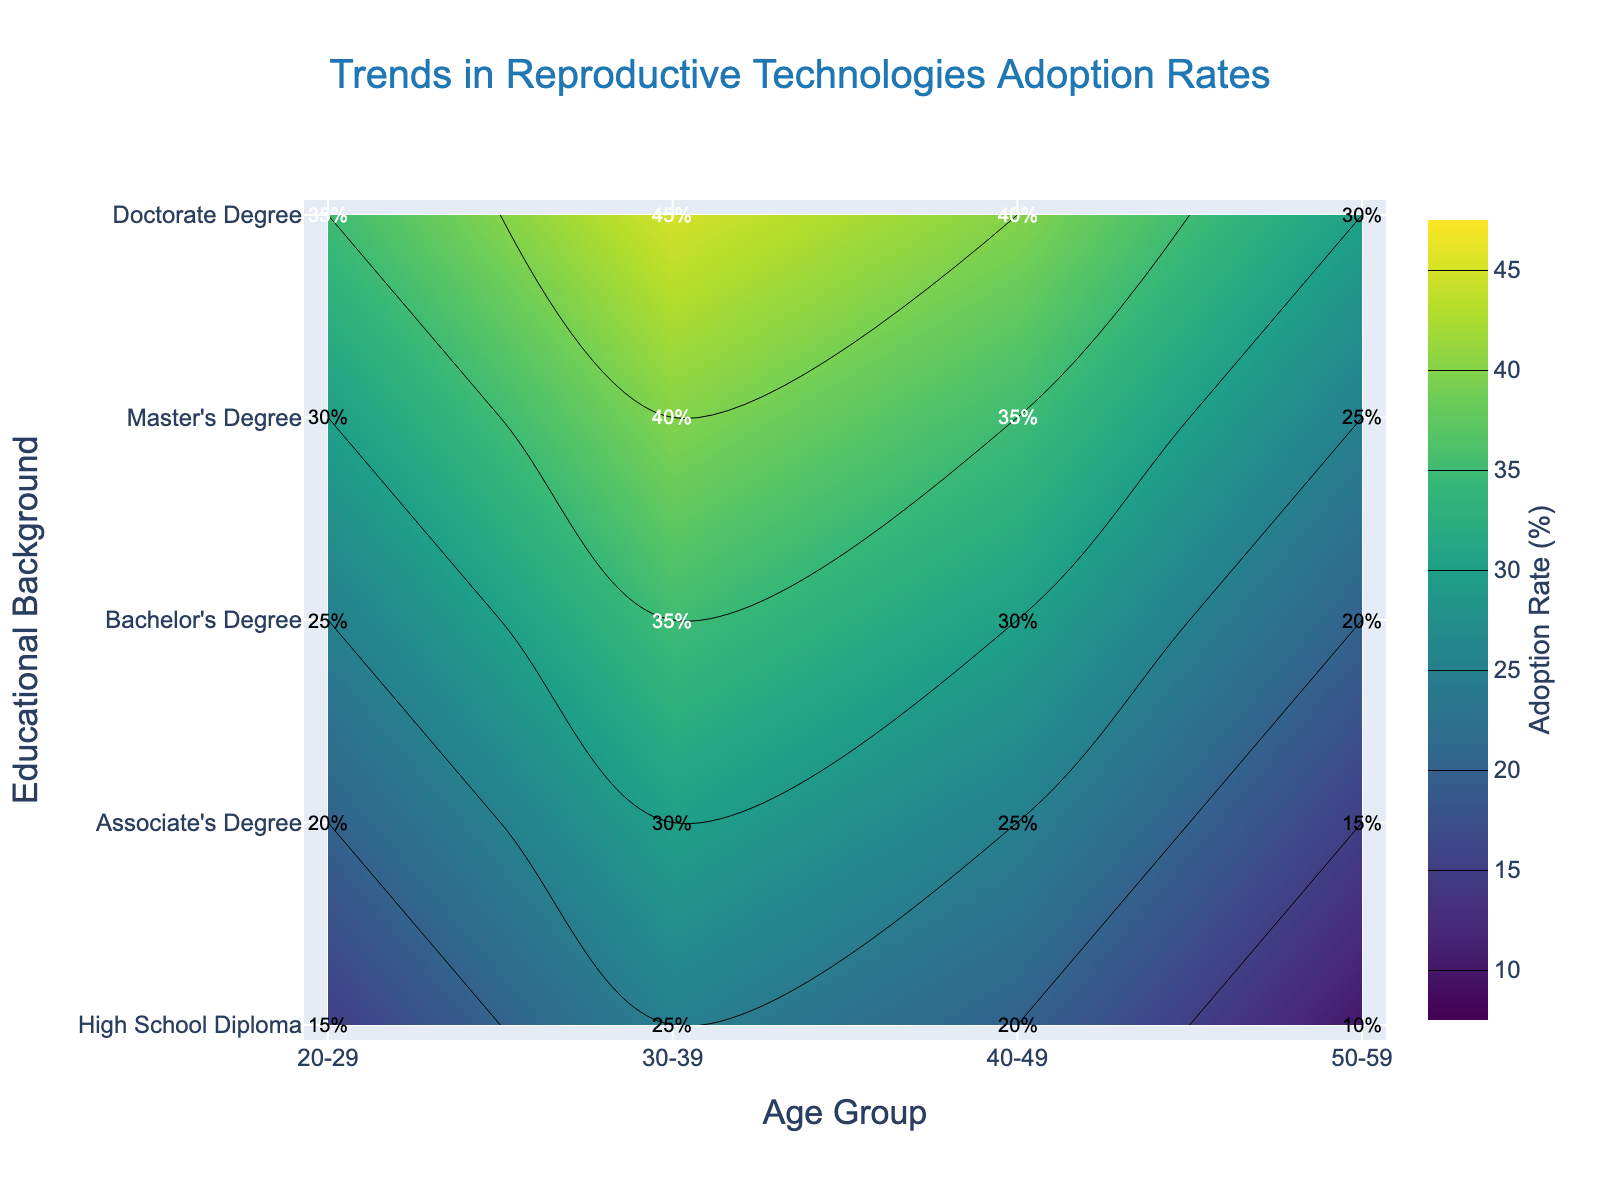What's the title of the figure? The title is always at the top of the figure and typically summarizes what the figure is about.
Answer: Trends in Reproductive Technologies Adoption Rates Which age group has the highest adoption rate for the Bachelor's Degree educational background? To find this, look at the contour plot for the Bachelor's Degree row and identify the age group with the highest value.
Answer: 30-39 What is the adoption rate for people with a Master's Degree aged 40-49? To answer this, locate the point where the Master's Degree row intersects the 40-49 age group column and read the value.
Answer: 35% Which educational background shows a steeper increase in adoption rate from age group 20-29 to 30-39, Master's Degree or Doctorate Degree? Compare the increase between the two age groups for both educational backgrounds by looking at the contour levels. Master's Degree increases from 30% to 40% (10% increase), while Doctorate Degree increases from 35% to 45% (10% increase) — same increase.
Answer: Both What is the difference in adoption rate between the Associate's Degree holders aged 30-39 and 50-59? Subtract the adoption rate for age group 50-59 from the adoption rate for age group 30-39 for Associate's Degree. 30% - 15% = 15%
Answer: 15% Compare the adoption rates for Doctorate Degree holders aged 40-49 and Master’s Degree holders aged 20-29. Which group has a higher adoption rate and by how much? Locate both values on the contour plot and subtract the smaller from the larger. Doctorate Degree holders aged 40-49 have a 40% adoption rate, Master’s Degree holders aged 20-29 have a 30% adoption rate. The difference is 40% - 30% = 10%.
Answer: Doctorate Degree by 10% What is the general trend in adoption rates across age groups for those with High School Diplomas? Observe the contour lines or values in the row for High School Diploma from left to right (20-29 to 50-59). The rates increase from 15% to 25%, then drop slightly to 20%, and significantly to 10%.
Answer: Increase, then decrease How does the adoption rate for Bachelor's Degree holders aged 50-59 compare to that for High School Diploma holders aged 30-39? Compare the values directly from the contour plot. Bachelor’s Degree holders aged 50-59 have a 20% rate, whereas High School Diploma holders aged 30-39 have a 25% rate.
Answer: High School Diploma holders aged 30-39 have a higher rate What is the average adoption rate for the Master's Degree educational background across all age groups? Add up the adoption rates for all age groups under Master's Degree and divide by the number of age groups: (30 + 40 + 35 + 25) / 4 = 130 / 4 = 32.5%
Answer: 32.5% Which age group exhibits the highest overall adoption rate, and what is that rate? Find the maximum value in the entire contour plot and read the corresponding age group. The highest adoption rate is 45% for the age group 30-39.
Answer: 30-39 